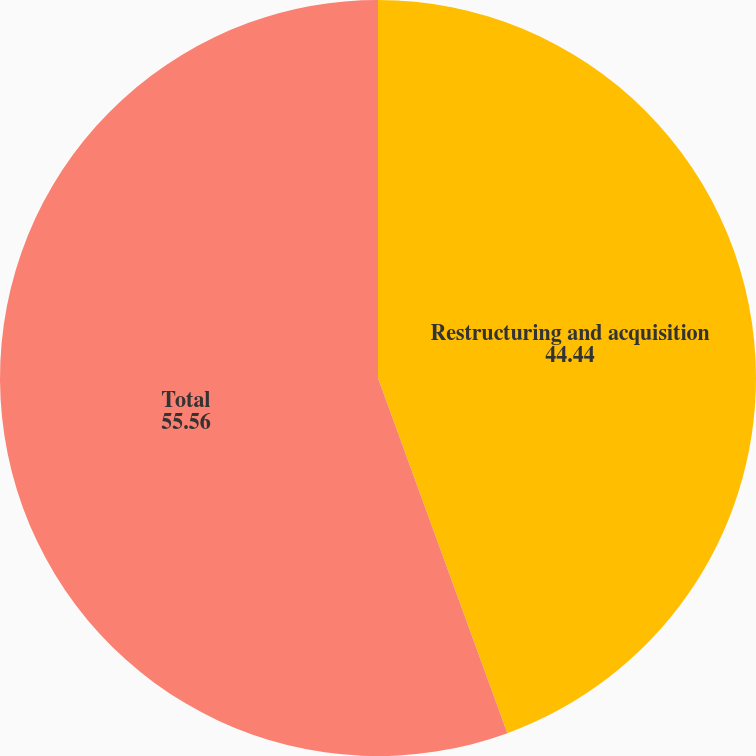Convert chart to OTSL. <chart><loc_0><loc_0><loc_500><loc_500><pie_chart><fcel>Restructuring and acquisition<fcel>Total<nl><fcel>44.44%<fcel>55.56%<nl></chart> 